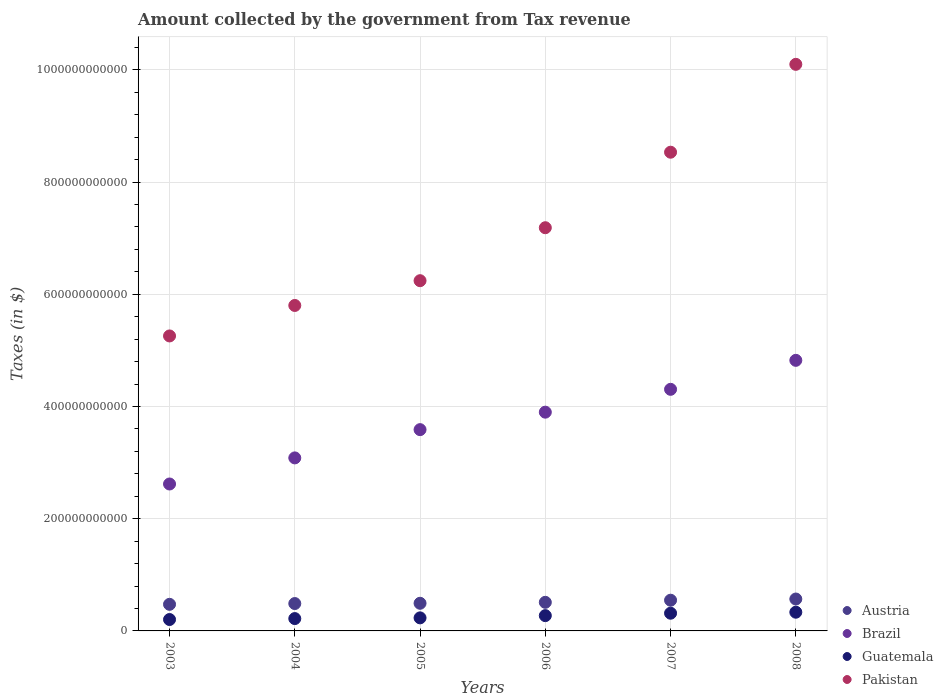How many different coloured dotlines are there?
Offer a very short reply. 4. What is the amount collected by the government from tax revenue in Brazil in 2005?
Your response must be concise. 3.59e+11. Across all years, what is the maximum amount collected by the government from tax revenue in Pakistan?
Provide a succinct answer. 1.01e+12. Across all years, what is the minimum amount collected by the government from tax revenue in Pakistan?
Your answer should be compact. 5.26e+11. In which year was the amount collected by the government from tax revenue in Brazil minimum?
Offer a terse response. 2003. What is the total amount collected by the government from tax revenue in Guatemala in the graph?
Keep it short and to the point. 1.58e+11. What is the difference between the amount collected by the government from tax revenue in Austria in 2003 and that in 2005?
Give a very brief answer. -1.86e+09. What is the difference between the amount collected by the government from tax revenue in Guatemala in 2003 and the amount collected by the government from tax revenue in Austria in 2007?
Give a very brief answer. -3.44e+1. What is the average amount collected by the government from tax revenue in Austria per year?
Give a very brief answer. 5.13e+1. In the year 2005, what is the difference between the amount collected by the government from tax revenue in Brazil and amount collected by the government from tax revenue in Guatemala?
Offer a very short reply. 3.35e+11. In how many years, is the amount collected by the government from tax revenue in Austria greater than 120000000000 $?
Your response must be concise. 0. What is the ratio of the amount collected by the government from tax revenue in Pakistan in 2003 to that in 2004?
Your answer should be compact. 0.91. Is the difference between the amount collected by the government from tax revenue in Brazil in 2007 and 2008 greater than the difference between the amount collected by the government from tax revenue in Guatemala in 2007 and 2008?
Your answer should be very brief. No. What is the difference between the highest and the second highest amount collected by the government from tax revenue in Brazil?
Ensure brevity in your answer.  5.17e+1. What is the difference between the highest and the lowest amount collected by the government from tax revenue in Guatemala?
Your response must be concise. 1.30e+1. In how many years, is the amount collected by the government from tax revenue in Pakistan greater than the average amount collected by the government from tax revenue in Pakistan taken over all years?
Ensure brevity in your answer.  3. Is the sum of the amount collected by the government from tax revenue in Brazil in 2005 and 2006 greater than the maximum amount collected by the government from tax revenue in Guatemala across all years?
Provide a short and direct response. Yes. Is it the case that in every year, the sum of the amount collected by the government from tax revenue in Guatemala and amount collected by the government from tax revenue in Austria  is greater than the sum of amount collected by the government from tax revenue in Brazil and amount collected by the government from tax revenue in Pakistan?
Your answer should be compact. Yes. Does the amount collected by the government from tax revenue in Pakistan monotonically increase over the years?
Your answer should be compact. Yes. Is the amount collected by the government from tax revenue in Pakistan strictly less than the amount collected by the government from tax revenue in Austria over the years?
Provide a short and direct response. No. How many dotlines are there?
Your answer should be very brief. 4. What is the difference between two consecutive major ticks on the Y-axis?
Ensure brevity in your answer.  2.00e+11. Are the values on the major ticks of Y-axis written in scientific E-notation?
Your answer should be very brief. No. Does the graph contain any zero values?
Keep it short and to the point. No. Where does the legend appear in the graph?
Provide a short and direct response. Bottom right. How many legend labels are there?
Your response must be concise. 4. What is the title of the graph?
Your response must be concise. Amount collected by the government from Tax revenue. Does "Euro area" appear as one of the legend labels in the graph?
Your answer should be very brief. No. What is the label or title of the X-axis?
Give a very brief answer. Years. What is the label or title of the Y-axis?
Offer a terse response. Taxes (in $). What is the Taxes (in $) of Austria in 2003?
Make the answer very short. 4.74e+1. What is the Taxes (in $) in Brazil in 2003?
Give a very brief answer. 2.62e+11. What is the Taxes (in $) of Guatemala in 2003?
Your answer should be very brief. 2.03e+1. What is the Taxes (in $) in Pakistan in 2003?
Your answer should be very brief. 5.26e+11. What is the Taxes (in $) in Austria in 2004?
Offer a very short reply. 4.88e+1. What is the Taxes (in $) of Brazil in 2004?
Your answer should be compact. 3.08e+11. What is the Taxes (in $) of Guatemala in 2004?
Your answer should be very brief. 2.20e+1. What is the Taxes (in $) in Pakistan in 2004?
Provide a short and direct response. 5.80e+11. What is the Taxes (in $) of Austria in 2005?
Ensure brevity in your answer.  4.93e+1. What is the Taxes (in $) in Brazil in 2005?
Your answer should be very brief. 3.59e+11. What is the Taxes (in $) of Guatemala in 2005?
Ensure brevity in your answer.  2.33e+1. What is the Taxes (in $) in Pakistan in 2005?
Provide a succinct answer. 6.24e+11. What is the Taxes (in $) of Austria in 2006?
Your response must be concise. 5.10e+1. What is the Taxes (in $) of Brazil in 2006?
Give a very brief answer. 3.90e+11. What is the Taxes (in $) in Guatemala in 2006?
Give a very brief answer. 2.73e+1. What is the Taxes (in $) of Pakistan in 2006?
Give a very brief answer. 7.19e+11. What is the Taxes (in $) of Austria in 2007?
Ensure brevity in your answer.  5.47e+1. What is the Taxes (in $) of Brazil in 2007?
Your answer should be compact. 4.31e+11. What is the Taxes (in $) of Guatemala in 2007?
Your answer should be very brief. 3.16e+1. What is the Taxes (in $) of Pakistan in 2007?
Keep it short and to the point. 8.53e+11. What is the Taxes (in $) of Austria in 2008?
Provide a short and direct response. 5.69e+1. What is the Taxes (in $) in Brazil in 2008?
Give a very brief answer. 4.82e+11. What is the Taxes (in $) in Guatemala in 2008?
Your response must be concise. 3.34e+1. What is the Taxes (in $) in Pakistan in 2008?
Your answer should be compact. 1.01e+12. Across all years, what is the maximum Taxes (in $) in Austria?
Your answer should be compact. 5.69e+1. Across all years, what is the maximum Taxes (in $) in Brazil?
Offer a terse response. 4.82e+11. Across all years, what is the maximum Taxes (in $) in Guatemala?
Make the answer very short. 3.34e+1. Across all years, what is the maximum Taxes (in $) of Pakistan?
Offer a terse response. 1.01e+12. Across all years, what is the minimum Taxes (in $) of Austria?
Ensure brevity in your answer.  4.74e+1. Across all years, what is the minimum Taxes (in $) of Brazil?
Offer a terse response. 2.62e+11. Across all years, what is the minimum Taxes (in $) of Guatemala?
Your response must be concise. 2.03e+1. Across all years, what is the minimum Taxes (in $) of Pakistan?
Give a very brief answer. 5.26e+11. What is the total Taxes (in $) of Austria in the graph?
Provide a short and direct response. 3.08e+11. What is the total Taxes (in $) of Brazil in the graph?
Your answer should be compact. 2.23e+12. What is the total Taxes (in $) in Guatemala in the graph?
Your response must be concise. 1.58e+11. What is the total Taxes (in $) in Pakistan in the graph?
Make the answer very short. 4.31e+12. What is the difference between the Taxes (in $) of Austria in 2003 and that in 2004?
Ensure brevity in your answer.  -1.38e+09. What is the difference between the Taxes (in $) in Brazil in 2003 and that in 2004?
Ensure brevity in your answer.  -4.65e+1. What is the difference between the Taxes (in $) in Guatemala in 2003 and that in 2004?
Provide a succinct answer. -1.68e+09. What is the difference between the Taxes (in $) in Pakistan in 2003 and that in 2004?
Offer a terse response. -5.43e+1. What is the difference between the Taxes (in $) of Austria in 2003 and that in 2005?
Your answer should be very brief. -1.86e+09. What is the difference between the Taxes (in $) in Brazil in 2003 and that in 2005?
Your answer should be very brief. -9.69e+1. What is the difference between the Taxes (in $) of Guatemala in 2003 and that in 2005?
Keep it short and to the point. -2.96e+09. What is the difference between the Taxes (in $) in Pakistan in 2003 and that in 2005?
Your response must be concise. -9.85e+1. What is the difference between the Taxes (in $) in Austria in 2003 and that in 2006?
Make the answer very short. -3.57e+09. What is the difference between the Taxes (in $) of Brazil in 2003 and that in 2006?
Your response must be concise. -1.28e+11. What is the difference between the Taxes (in $) of Guatemala in 2003 and that in 2006?
Make the answer very short. -6.93e+09. What is the difference between the Taxes (in $) of Pakistan in 2003 and that in 2006?
Offer a terse response. -1.93e+11. What is the difference between the Taxes (in $) of Austria in 2003 and that in 2007?
Provide a short and direct response. -7.33e+09. What is the difference between the Taxes (in $) in Brazil in 2003 and that in 2007?
Keep it short and to the point. -1.69e+11. What is the difference between the Taxes (in $) in Guatemala in 2003 and that in 2007?
Ensure brevity in your answer.  -1.12e+1. What is the difference between the Taxes (in $) of Pakistan in 2003 and that in 2007?
Offer a very short reply. -3.27e+11. What is the difference between the Taxes (in $) in Austria in 2003 and that in 2008?
Make the answer very short. -9.44e+09. What is the difference between the Taxes (in $) in Brazil in 2003 and that in 2008?
Offer a very short reply. -2.20e+11. What is the difference between the Taxes (in $) in Guatemala in 2003 and that in 2008?
Provide a short and direct response. -1.30e+1. What is the difference between the Taxes (in $) in Pakistan in 2003 and that in 2008?
Provide a succinct answer. -4.84e+11. What is the difference between the Taxes (in $) of Austria in 2004 and that in 2005?
Keep it short and to the point. -4.75e+08. What is the difference between the Taxes (in $) of Brazil in 2004 and that in 2005?
Provide a succinct answer. -5.04e+1. What is the difference between the Taxes (in $) in Guatemala in 2004 and that in 2005?
Your answer should be very brief. -1.28e+09. What is the difference between the Taxes (in $) of Pakistan in 2004 and that in 2005?
Make the answer very short. -4.42e+1. What is the difference between the Taxes (in $) of Austria in 2004 and that in 2006?
Provide a short and direct response. -2.19e+09. What is the difference between the Taxes (in $) of Brazil in 2004 and that in 2006?
Offer a terse response. -8.15e+1. What is the difference between the Taxes (in $) in Guatemala in 2004 and that in 2006?
Provide a succinct answer. -5.25e+09. What is the difference between the Taxes (in $) in Pakistan in 2004 and that in 2006?
Provide a short and direct response. -1.39e+11. What is the difference between the Taxes (in $) in Austria in 2004 and that in 2007?
Your answer should be very brief. -5.95e+09. What is the difference between the Taxes (in $) of Brazil in 2004 and that in 2007?
Your response must be concise. -1.22e+11. What is the difference between the Taxes (in $) of Guatemala in 2004 and that in 2007?
Ensure brevity in your answer.  -9.57e+09. What is the difference between the Taxes (in $) in Pakistan in 2004 and that in 2007?
Your answer should be very brief. -2.73e+11. What is the difference between the Taxes (in $) in Austria in 2004 and that in 2008?
Make the answer very short. -8.06e+09. What is the difference between the Taxes (in $) in Brazil in 2004 and that in 2008?
Your answer should be very brief. -1.74e+11. What is the difference between the Taxes (in $) of Guatemala in 2004 and that in 2008?
Your answer should be very brief. -1.14e+1. What is the difference between the Taxes (in $) in Pakistan in 2004 and that in 2008?
Keep it short and to the point. -4.30e+11. What is the difference between the Taxes (in $) in Austria in 2005 and that in 2006?
Provide a short and direct response. -1.71e+09. What is the difference between the Taxes (in $) in Brazil in 2005 and that in 2006?
Ensure brevity in your answer.  -3.11e+1. What is the difference between the Taxes (in $) in Guatemala in 2005 and that in 2006?
Make the answer very short. -3.97e+09. What is the difference between the Taxes (in $) of Pakistan in 2005 and that in 2006?
Your response must be concise. -9.44e+1. What is the difference between the Taxes (in $) in Austria in 2005 and that in 2007?
Provide a short and direct response. -5.47e+09. What is the difference between the Taxes (in $) of Brazil in 2005 and that in 2007?
Provide a succinct answer. -7.19e+1. What is the difference between the Taxes (in $) in Guatemala in 2005 and that in 2007?
Your answer should be compact. -8.29e+09. What is the difference between the Taxes (in $) of Pakistan in 2005 and that in 2007?
Make the answer very short. -2.29e+11. What is the difference between the Taxes (in $) in Austria in 2005 and that in 2008?
Provide a succinct answer. -7.59e+09. What is the difference between the Taxes (in $) of Brazil in 2005 and that in 2008?
Ensure brevity in your answer.  -1.24e+11. What is the difference between the Taxes (in $) of Guatemala in 2005 and that in 2008?
Offer a terse response. -1.01e+1. What is the difference between the Taxes (in $) of Pakistan in 2005 and that in 2008?
Provide a short and direct response. -3.86e+11. What is the difference between the Taxes (in $) in Austria in 2006 and that in 2007?
Make the answer very short. -3.76e+09. What is the difference between the Taxes (in $) in Brazil in 2006 and that in 2007?
Ensure brevity in your answer.  -4.07e+1. What is the difference between the Taxes (in $) in Guatemala in 2006 and that in 2007?
Make the answer very short. -4.32e+09. What is the difference between the Taxes (in $) in Pakistan in 2006 and that in 2007?
Your answer should be compact. -1.35e+11. What is the difference between the Taxes (in $) of Austria in 2006 and that in 2008?
Provide a short and direct response. -5.88e+09. What is the difference between the Taxes (in $) in Brazil in 2006 and that in 2008?
Your answer should be compact. -9.24e+1. What is the difference between the Taxes (in $) in Guatemala in 2006 and that in 2008?
Ensure brevity in your answer.  -6.10e+09. What is the difference between the Taxes (in $) in Pakistan in 2006 and that in 2008?
Keep it short and to the point. -2.91e+11. What is the difference between the Taxes (in $) of Austria in 2007 and that in 2008?
Your answer should be compact. -2.12e+09. What is the difference between the Taxes (in $) in Brazil in 2007 and that in 2008?
Offer a terse response. -5.17e+1. What is the difference between the Taxes (in $) of Guatemala in 2007 and that in 2008?
Your response must be concise. -1.79e+09. What is the difference between the Taxes (in $) of Pakistan in 2007 and that in 2008?
Provide a succinct answer. -1.57e+11. What is the difference between the Taxes (in $) of Austria in 2003 and the Taxes (in $) of Brazil in 2004?
Your answer should be compact. -2.61e+11. What is the difference between the Taxes (in $) of Austria in 2003 and the Taxes (in $) of Guatemala in 2004?
Offer a terse response. 2.54e+1. What is the difference between the Taxes (in $) of Austria in 2003 and the Taxes (in $) of Pakistan in 2004?
Your answer should be compact. -5.33e+11. What is the difference between the Taxes (in $) of Brazil in 2003 and the Taxes (in $) of Guatemala in 2004?
Provide a succinct answer. 2.40e+11. What is the difference between the Taxes (in $) in Brazil in 2003 and the Taxes (in $) in Pakistan in 2004?
Ensure brevity in your answer.  -3.18e+11. What is the difference between the Taxes (in $) of Guatemala in 2003 and the Taxes (in $) of Pakistan in 2004?
Give a very brief answer. -5.60e+11. What is the difference between the Taxes (in $) in Austria in 2003 and the Taxes (in $) in Brazil in 2005?
Your response must be concise. -3.11e+11. What is the difference between the Taxes (in $) of Austria in 2003 and the Taxes (in $) of Guatemala in 2005?
Offer a terse response. 2.41e+1. What is the difference between the Taxes (in $) in Austria in 2003 and the Taxes (in $) in Pakistan in 2005?
Your answer should be very brief. -5.77e+11. What is the difference between the Taxes (in $) of Brazil in 2003 and the Taxes (in $) of Guatemala in 2005?
Your response must be concise. 2.39e+11. What is the difference between the Taxes (in $) of Brazil in 2003 and the Taxes (in $) of Pakistan in 2005?
Your answer should be compact. -3.62e+11. What is the difference between the Taxes (in $) of Guatemala in 2003 and the Taxes (in $) of Pakistan in 2005?
Offer a terse response. -6.04e+11. What is the difference between the Taxes (in $) of Austria in 2003 and the Taxes (in $) of Brazil in 2006?
Keep it short and to the point. -3.42e+11. What is the difference between the Taxes (in $) of Austria in 2003 and the Taxes (in $) of Guatemala in 2006?
Ensure brevity in your answer.  2.02e+1. What is the difference between the Taxes (in $) of Austria in 2003 and the Taxes (in $) of Pakistan in 2006?
Ensure brevity in your answer.  -6.71e+11. What is the difference between the Taxes (in $) in Brazil in 2003 and the Taxes (in $) in Guatemala in 2006?
Keep it short and to the point. 2.35e+11. What is the difference between the Taxes (in $) of Brazil in 2003 and the Taxes (in $) of Pakistan in 2006?
Offer a terse response. -4.57e+11. What is the difference between the Taxes (in $) of Guatemala in 2003 and the Taxes (in $) of Pakistan in 2006?
Provide a succinct answer. -6.98e+11. What is the difference between the Taxes (in $) in Austria in 2003 and the Taxes (in $) in Brazil in 2007?
Your answer should be compact. -3.83e+11. What is the difference between the Taxes (in $) in Austria in 2003 and the Taxes (in $) in Guatemala in 2007?
Your answer should be compact. 1.58e+1. What is the difference between the Taxes (in $) of Austria in 2003 and the Taxes (in $) of Pakistan in 2007?
Provide a succinct answer. -8.06e+11. What is the difference between the Taxes (in $) in Brazil in 2003 and the Taxes (in $) in Guatemala in 2007?
Your answer should be compact. 2.30e+11. What is the difference between the Taxes (in $) of Brazil in 2003 and the Taxes (in $) of Pakistan in 2007?
Provide a short and direct response. -5.91e+11. What is the difference between the Taxes (in $) of Guatemala in 2003 and the Taxes (in $) of Pakistan in 2007?
Offer a very short reply. -8.33e+11. What is the difference between the Taxes (in $) in Austria in 2003 and the Taxes (in $) in Brazil in 2008?
Your response must be concise. -4.35e+11. What is the difference between the Taxes (in $) in Austria in 2003 and the Taxes (in $) in Guatemala in 2008?
Your answer should be compact. 1.41e+1. What is the difference between the Taxes (in $) of Austria in 2003 and the Taxes (in $) of Pakistan in 2008?
Provide a succinct answer. -9.62e+11. What is the difference between the Taxes (in $) of Brazil in 2003 and the Taxes (in $) of Guatemala in 2008?
Provide a succinct answer. 2.29e+11. What is the difference between the Taxes (in $) in Brazil in 2003 and the Taxes (in $) in Pakistan in 2008?
Provide a succinct answer. -7.48e+11. What is the difference between the Taxes (in $) in Guatemala in 2003 and the Taxes (in $) in Pakistan in 2008?
Your answer should be very brief. -9.90e+11. What is the difference between the Taxes (in $) in Austria in 2004 and the Taxes (in $) in Brazil in 2005?
Your answer should be compact. -3.10e+11. What is the difference between the Taxes (in $) of Austria in 2004 and the Taxes (in $) of Guatemala in 2005?
Keep it short and to the point. 2.55e+1. What is the difference between the Taxes (in $) in Austria in 2004 and the Taxes (in $) in Pakistan in 2005?
Your answer should be very brief. -5.75e+11. What is the difference between the Taxes (in $) of Brazil in 2004 and the Taxes (in $) of Guatemala in 2005?
Provide a short and direct response. 2.85e+11. What is the difference between the Taxes (in $) in Brazil in 2004 and the Taxes (in $) in Pakistan in 2005?
Give a very brief answer. -3.16e+11. What is the difference between the Taxes (in $) in Guatemala in 2004 and the Taxes (in $) in Pakistan in 2005?
Provide a succinct answer. -6.02e+11. What is the difference between the Taxes (in $) of Austria in 2004 and the Taxes (in $) of Brazil in 2006?
Your answer should be very brief. -3.41e+11. What is the difference between the Taxes (in $) in Austria in 2004 and the Taxes (in $) in Guatemala in 2006?
Make the answer very short. 2.15e+1. What is the difference between the Taxes (in $) in Austria in 2004 and the Taxes (in $) in Pakistan in 2006?
Ensure brevity in your answer.  -6.70e+11. What is the difference between the Taxes (in $) in Brazil in 2004 and the Taxes (in $) in Guatemala in 2006?
Offer a very short reply. 2.81e+11. What is the difference between the Taxes (in $) in Brazil in 2004 and the Taxes (in $) in Pakistan in 2006?
Provide a short and direct response. -4.10e+11. What is the difference between the Taxes (in $) in Guatemala in 2004 and the Taxes (in $) in Pakistan in 2006?
Provide a short and direct response. -6.97e+11. What is the difference between the Taxes (in $) of Austria in 2004 and the Taxes (in $) of Brazil in 2007?
Your answer should be compact. -3.82e+11. What is the difference between the Taxes (in $) of Austria in 2004 and the Taxes (in $) of Guatemala in 2007?
Provide a short and direct response. 1.72e+1. What is the difference between the Taxes (in $) of Austria in 2004 and the Taxes (in $) of Pakistan in 2007?
Make the answer very short. -8.04e+11. What is the difference between the Taxes (in $) of Brazil in 2004 and the Taxes (in $) of Guatemala in 2007?
Your answer should be very brief. 2.77e+11. What is the difference between the Taxes (in $) in Brazil in 2004 and the Taxes (in $) in Pakistan in 2007?
Your answer should be compact. -5.45e+11. What is the difference between the Taxes (in $) in Guatemala in 2004 and the Taxes (in $) in Pakistan in 2007?
Provide a succinct answer. -8.31e+11. What is the difference between the Taxes (in $) in Austria in 2004 and the Taxes (in $) in Brazil in 2008?
Give a very brief answer. -4.34e+11. What is the difference between the Taxes (in $) in Austria in 2004 and the Taxes (in $) in Guatemala in 2008?
Make the answer very short. 1.54e+1. What is the difference between the Taxes (in $) in Austria in 2004 and the Taxes (in $) in Pakistan in 2008?
Your response must be concise. -9.61e+11. What is the difference between the Taxes (in $) in Brazil in 2004 and the Taxes (in $) in Guatemala in 2008?
Make the answer very short. 2.75e+11. What is the difference between the Taxes (in $) in Brazil in 2004 and the Taxes (in $) in Pakistan in 2008?
Keep it short and to the point. -7.02e+11. What is the difference between the Taxes (in $) of Guatemala in 2004 and the Taxes (in $) of Pakistan in 2008?
Offer a terse response. -9.88e+11. What is the difference between the Taxes (in $) in Austria in 2005 and the Taxes (in $) in Brazil in 2006?
Keep it short and to the point. -3.41e+11. What is the difference between the Taxes (in $) of Austria in 2005 and the Taxes (in $) of Guatemala in 2006?
Your response must be concise. 2.20e+1. What is the difference between the Taxes (in $) of Austria in 2005 and the Taxes (in $) of Pakistan in 2006?
Offer a very short reply. -6.69e+11. What is the difference between the Taxes (in $) of Brazil in 2005 and the Taxes (in $) of Guatemala in 2006?
Keep it short and to the point. 3.32e+11. What is the difference between the Taxes (in $) in Brazil in 2005 and the Taxes (in $) in Pakistan in 2006?
Offer a terse response. -3.60e+11. What is the difference between the Taxes (in $) in Guatemala in 2005 and the Taxes (in $) in Pakistan in 2006?
Keep it short and to the point. -6.95e+11. What is the difference between the Taxes (in $) in Austria in 2005 and the Taxes (in $) in Brazil in 2007?
Offer a terse response. -3.81e+11. What is the difference between the Taxes (in $) in Austria in 2005 and the Taxes (in $) in Guatemala in 2007?
Give a very brief answer. 1.77e+1. What is the difference between the Taxes (in $) of Austria in 2005 and the Taxes (in $) of Pakistan in 2007?
Offer a terse response. -8.04e+11. What is the difference between the Taxes (in $) of Brazil in 2005 and the Taxes (in $) of Guatemala in 2007?
Ensure brevity in your answer.  3.27e+11. What is the difference between the Taxes (in $) of Brazil in 2005 and the Taxes (in $) of Pakistan in 2007?
Your answer should be very brief. -4.94e+11. What is the difference between the Taxes (in $) in Guatemala in 2005 and the Taxes (in $) in Pakistan in 2007?
Your answer should be very brief. -8.30e+11. What is the difference between the Taxes (in $) in Austria in 2005 and the Taxes (in $) in Brazil in 2008?
Your answer should be very brief. -4.33e+11. What is the difference between the Taxes (in $) in Austria in 2005 and the Taxes (in $) in Guatemala in 2008?
Ensure brevity in your answer.  1.59e+1. What is the difference between the Taxes (in $) of Austria in 2005 and the Taxes (in $) of Pakistan in 2008?
Make the answer very short. -9.61e+11. What is the difference between the Taxes (in $) of Brazil in 2005 and the Taxes (in $) of Guatemala in 2008?
Provide a succinct answer. 3.25e+11. What is the difference between the Taxes (in $) of Brazil in 2005 and the Taxes (in $) of Pakistan in 2008?
Provide a short and direct response. -6.51e+11. What is the difference between the Taxes (in $) in Guatemala in 2005 and the Taxes (in $) in Pakistan in 2008?
Your answer should be compact. -9.87e+11. What is the difference between the Taxes (in $) in Austria in 2006 and the Taxes (in $) in Brazil in 2007?
Your response must be concise. -3.80e+11. What is the difference between the Taxes (in $) of Austria in 2006 and the Taxes (in $) of Guatemala in 2007?
Your answer should be compact. 1.94e+1. What is the difference between the Taxes (in $) of Austria in 2006 and the Taxes (in $) of Pakistan in 2007?
Give a very brief answer. -8.02e+11. What is the difference between the Taxes (in $) in Brazil in 2006 and the Taxes (in $) in Guatemala in 2007?
Provide a short and direct response. 3.58e+11. What is the difference between the Taxes (in $) of Brazil in 2006 and the Taxes (in $) of Pakistan in 2007?
Give a very brief answer. -4.63e+11. What is the difference between the Taxes (in $) of Guatemala in 2006 and the Taxes (in $) of Pakistan in 2007?
Offer a terse response. -8.26e+11. What is the difference between the Taxes (in $) in Austria in 2006 and the Taxes (in $) in Brazil in 2008?
Give a very brief answer. -4.31e+11. What is the difference between the Taxes (in $) of Austria in 2006 and the Taxes (in $) of Guatemala in 2008?
Your answer should be very brief. 1.76e+1. What is the difference between the Taxes (in $) in Austria in 2006 and the Taxes (in $) in Pakistan in 2008?
Provide a short and direct response. -9.59e+11. What is the difference between the Taxes (in $) in Brazil in 2006 and the Taxes (in $) in Guatemala in 2008?
Your response must be concise. 3.57e+11. What is the difference between the Taxes (in $) in Brazil in 2006 and the Taxes (in $) in Pakistan in 2008?
Offer a very short reply. -6.20e+11. What is the difference between the Taxes (in $) of Guatemala in 2006 and the Taxes (in $) of Pakistan in 2008?
Offer a very short reply. -9.83e+11. What is the difference between the Taxes (in $) in Austria in 2007 and the Taxes (in $) in Brazil in 2008?
Give a very brief answer. -4.28e+11. What is the difference between the Taxes (in $) of Austria in 2007 and the Taxes (in $) of Guatemala in 2008?
Provide a short and direct response. 2.14e+1. What is the difference between the Taxes (in $) in Austria in 2007 and the Taxes (in $) in Pakistan in 2008?
Provide a short and direct response. -9.55e+11. What is the difference between the Taxes (in $) of Brazil in 2007 and the Taxes (in $) of Guatemala in 2008?
Your response must be concise. 3.97e+11. What is the difference between the Taxes (in $) in Brazil in 2007 and the Taxes (in $) in Pakistan in 2008?
Make the answer very short. -5.79e+11. What is the difference between the Taxes (in $) of Guatemala in 2007 and the Taxes (in $) of Pakistan in 2008?
Give a very brief answer. -9.78e+11. What is the average Taxes (in $) in Austria per year?
Keep it short and to the point. 5.13e+1. What is the average Taxes (in $) of Brazil per year?
Give a very brief answer. 3.72e+11. What is the average Taxes (in $) in Guatemala per year?
Your answer should be very brief. 2.63e+1. What is the average Taxes (in $) of Pakistan per year?
Ensure brevity in your answer.  7.19e+11. In the year 2003, what is the difference between the Taxes (in $) in Austria and Taxes (in $) in Brazil?
Offer a terse response. -2.14e+11. In the year 2003, what is the difference between the Taxes (in $) of Austria and Taxes (in $) of Guatemala?
Offer a terse response. 2.71e+1. In the year 2003, what is the difference between the Taxes (in $) of Austria and Taxes (in $) of Pakistan?
Provide a short and direct response. -4.78e+11. In the year 2003, what is the difference between the Taxes (in $) in Brazil and Taxes (in $) in Guatemala?
Provide a succinct answer. 2.42e+11. In the year 2003, what is the difference between the Taxes (in $) of Brazil and Taxes (in $) of Pakistan?
Provide a short and direct response. -2.64e+11. In the year 2003, what is the difference between the Taxes (in $) in Guatemala and Taxes (in $) in Pakistan?
Give a very brief answer. -5.05e+11. In the year 2004, what is the difference between the Taxes (in $) of Austria and Taxes (in $) of Brazil?
Give a very brief answer. -2.60e+11. In the year 2004, what is the difference between the Taxes (in $) in Austria and Taxes (in $) in Guatemala?
Your answer should be compact. 2.68e+1. In the year 2004, what is the difference between the Taxes (in $) in Austria and Taxes (in $) in Pakistan?
Your answer should be compact. -5.31e+11. In the year 2004, what is the difference between the Taxes (in $) in Brazil and Taxes (in $) in Guatemala?
Your answer should be very brief. 2.86e+11. In the year 2004, what is the difference between the Taxes (in $) of Brazil and Taxes (in $) of Pakistan?
Your answer should be compact. -2.72e+11. In the year 2004, what is the difference between the Taxes (in $) of Guatemala and Taxes (in $) of Pakistan?
Your response must be concise. -5.58e+11. In the year 2005, what is the difference between the Taxes (in $) of Austria and Taxes (in $) of Brazil?
Provide a succinct answer. -3.10e+11. In the year 2005, what is the difference between the Taxes (in $) of Austria and Taxes (in $) of Guatemala?
Keep it short and to the point. 2.60e+1. In the year 2005, what is the difference between the Taxes (in $) in Austria and Taxes (in $) in Pakistan?
Make the answer very short. -5.75e+11. In the year 2005, what is the difference between the Taxes (in $) in Brazil and Taxes (in $) in Guatemala?
Ensure brevity in your answer.  3.35e+11. In the year 2005, what is the difference between the Taxes (in $) in Brazil and Taxes (in $) in Pakistan?
Offer a terse response. -2.65e+11. In the year 2005, what is the difference between the Taxes (in $) in Guatemala and Taxes (in $) in Pakistan?
Offer a terse response. -6.01e+11. In the year 2006, what is the difference between the Taxes (in $) in Austria and Taxes (in $) in Brazil?
Offer a terse response. -3.39e+11. In the year 2006, what is the difference between the Taxes (in $) of Austria and Taxes (in $) of Guatemala?
Give a very brief answer. 2.37e+1. In the year 2006, what is the difference between the Taxes (in $) in Austria and Taxes (in $) in Pakistan?
Keep it short and to the point. -6.68e+11. In the year 2006, what is the difference between the Taxes (in $) in Brazil and Taxes (in $) in Guatemala?
Provide a succinct answer. 3.63e+11. In the year 2006, what is the difference between the Taxes (in $) of Brazil and Taxes (in $) of Pakistan?
Provide a succinct answer. -3.29e+11. In the year 2006, what is the difference between the Taxes (in $) in Guatemala and Taxes (in $) in Pakistan?
Ensure brevity in your answer.  -6.91e+11. In the year 2007, what is the difference between the Taxes (in $) in Austria and Taxes (in $) in Brazil?
Provide a short and direct response. -3.76e+11. In the year 2007, what is the difference between the Taxes (in $) in Austria and Taxes (in $) in Guatemala?
Provide a short and direct response. 2.32e+1. In the year 2007, what is the difference between the Taxes (in $) in Austria and Taxes (in $) in Pakistan?
Give a very brief answer. -7.99e+11. In the year 2007, what is the difference between the Taxes (in $) of Brazil and Taxes (in $) of Guatemala?
Offer a very short reply. 3.99e+11. In the year 2007, what is the difference between the Taxes (in $) in Brazil and Taxes (in $) in Pakistan?
Your response must be concise. -4.23e+11. In the year 2007, what is the difference between the Taxes (in $) in Guatemala and Taxes (in $) in Pakistan?
Your answer should be very brief. -8.22e+11. In the year 2008, what is the difference between the Taxes (in $) in Austria and Taxes (in $) in Brazil?
Keep it short and to the point. -4.25e+11. In the year 2008, what is the difference between the Taxes (in $) of Austria and Taxes (in $) of Guatemala?
Offer a terse response. 2.35e+1. In the year 2008, what is the difference between the Taxes (in $) of Austria and Taxes (in $) of Pakistan?
Make the answer very short. -9.53e+11. In the year 2008, what is the difference between the Taxes (in $) in Brazil and Taxes (in $) in Guatemala?
Your response must be concise. 4.49e+11. In the year 2008, what is the difference between the Taxes (in $) of Brazil and Taxes (in $) of Pakistan?
Offer a terse response. -5.28e+11. In the year 2008, what is the difference between the Taxes (in $) in Guatemala and Taxes (in $) in Pakistan?
Offer a very short reply. -9.77e+11. What is the ratio of the Taxes (in $) of Austria in 2003 to that in 2004?
Offer a terse response. 0.97. What is the ratio of the Taxes (in $) in Brazil in 2003 to that in 2004?
Provide a short and direct response. 0.85. What is the ratio of the Taxes (in $) in Guatemala in 2003 to that in 2004?
Your response must be concise. 0.92. What is the ratio of the Taxes (in $) in Pakistan in 2003 to that in 2004?
Ensure brevity in your answer.  0.91. What is the ratio of the Taxes (in $) in Austria in 2003 to that in 2005?
Offer a terse response. 0.96. What is the ratio of the Taxes (in $) in Brazil in 2003 to that in 2005?
Offer a terse response. 0.73. What is the ratio of the Taxes (in $) in Guatemala in 2003 to that in 2005?
Your answer should be compact. 0.87. What is the ratio of the Taxes (in $) of Pakistan in 2003 to that in 2005?
Provide a short and direct response. 0.84. What is the ratio of the Taxes (in $) of Brazil in 2003 to that in 2006?
Offer a terse response. 0.67. What is the ratio of the Taxes (in $) in Guatemala in 2003 to that in 2006?
Your response must be concise. 0.75. What is the ratio of the Taxes (in $) of Pakistan in 2003 to that in 2006?
Keep it short and to the point. 0.73. What is the ratio of the Taxes (in $) in Austria in 2003 to that in 2007?
Your response must be concise. 0.87. What is the ratio of the Taxes (in $) of Brazil in 2003 to that in 2007?
Offer a terse response. 0.61. What is the ratio of the Taxes (in $) in Guatemala in 2003 to that in 2007?
Ensure brevity in your answer.  0.64. What is the ratio of the Taxes (in $) of Pakistan in 2003 to that in 2007?
Offer a terse response. 0.62. What is the ratio of the Taxes (in $) in Austria in 2003 to that in 2008?
Provide a succinct answer. 0.83. What is the ratio of the Taxes (in $) in Brazil in 2003 to that in 2008?
Offer a very short reply. 0.54. What is the ratio of the Taxes (in $) in Guatemala in 2003 to that in 2008?
Your response must be concise. 0.61. What is the ratio of the Taxes (in $) of Pakistan in 2003 to that in 2008?
Provide a short and direct response. 0.52. What is the ratio of the Taxes (in $) in Austria in 2004 to that in 2005?
Offer a very short reply. 0.99. What is the ratio of the Taxes (in $) in Brazil in 2004 to that in 2005?
Ensure brevity in your answer.  0.86. What is the ratio of the Taxes (in $) of Guatemala in 2004 to that in 2005?
Provide a short and direct response. 0.95. What is the ratio of the Taxes (in $) of Pakistan in 2004 to that in 2005?
Offer a very short reply. 0.93. What is the ratio of the Taxes (in $) in Austria in 2004 to that in 2006?
Your answer should be very brief. 0.96. What is the ratio of the Taxes (in $) in Brazil in 2004 to that in 2006?
Provide a succinct answer. 0.79. What is the ratio of the Taxes (in $) in Guatemala in 2004 to that in 2006?
Provide a succinct answer. 0.81. What is the ratio of the Taxes (in $) of Pakistan in 2004 to that in 2006?
Offer a terse response. 0.81. What is the ratio of the Taxes (in $) in Austria in 2004 to that in 2007?
Make the answer very short. 0.89. What is the ratio of the Taxes (in $) in Brazil in 2004 to that in 2007?
Offer a very short reply. 0.72. What is the ratio of the Taxes (in $) of Guatemala in 2004 to that in 2007?
Offer a very short reply. 0.7. What is the ratio of the Taxes (in $) of Pakistan in 2004 to that in 2007?
Give a very brief answer. 0.68. What is the ratio of the Taxes (in $) in Austria in 2004 to that in 2008?
Ensure brevity in your answer.  0.86. What is the ratio of the Taxes (in $) of Brazil in 2004 to that in 2008?
Give a very brief answer. 0.64. What is the ratio of the Taxes (in $) of Guatemala in 2004 to that in 2008?
Give a very brief answer. 0.66. What is the ratio of the Taxes (in $) of Pakistan in 2004 to that in 2008?
Offer a very short reply. 0.57. What is the ratio of the Taxes (in $) of Austria in 2005 to that in 2006?
Ensure brevity in your answer.  0.97. What is the ratio of the Taxes (in $) in Brazil in 2005 to that in 2006?
Your answer should be compact. 0.92. What is the ratio of the Taxes (in $) of Guatemala in 2005 to that in 2006?
Make the answer very short. 0.85. What is the ratio of the Taxes (in $) in Pakistan in 2005 to that in 2006?
Your answer should be very brief. 0.87. What is the ratio of the Taxes (in $) of Brazil in 2005 to that in 2007?
Provide a short and direct response. 0.83. What is the ratio of the Taxes (in $) of Guatemala in 2005 to that in 2007?
Provide a short and direct response. 0.74. What is the ratio of the Taxes (in $) in Pakistan in 2005 to that in 2007?
Your answer should be very brief. 0.73. What is the ratio of the Taxes (in $) of Austria in 2005 to that in 2008?
Provide a short and direct response. 0.87. What is the ratio of the Taxes (in $) of Brazil in 2005 to that in 2008?
Provide a succinct answer. 0.74. What is the ratio of the Taxes (in $) of Guatemala in 2005 to that in 2008?
Your answer should be very brief. 0.7. What is the ratio of the Taxes (in $) of Pakistan in 2005 to that in 2008?
Offer a terse response. 0.62. What is the ratio of the Taxes (in $) of Austria in 2006 to that in 2007?
Your answer should be compact. 0.93. What is the ratio of the Taxes (in $) in Brazil in 2006 to that in 2007?
Provide a succinct answer. 0.91. What is the ratio of the Taxes (in $) of Guatemala in 2006 to that in 2007?
Your response must be concise. 0.86. What is the ratio of the Taxes (in $) in Pakistan in 2006 to that in 2007?
Make the answer very short. 0.84. What is the ratio of the Taxes (in $) in Austria in 2006 to that in 2008?
Make the answer very short. 0.9. What is the ratio of the Taxes (in $) in Brazil in 2006 to that in 2008?
Ensure brevity in your answer.  0.81. What is the ratio of the Taxes (in $) of Guatemala in 2006 to that in 2008?
Make the answer very short. 0.82. What is the ratio of the Taxes (in $) of Pakistan in 2006 to that in 2008?
Your response must be concise. 0.71. What is the ratio of the Taxes (in $) of Austria in 2007 to that in 2008?
Your response must be concise. 0.96. What is the ratio of the Taxes (in $) in Brazil in 2007 to that in 2008?
Keep it short and to the point. 0.89. What is the ratio of the Taxes (in $) in Guatemala in 2007 to that in 2008?
Keep it short and to the point. 0.95. What is the ratio of the Taxes (in $) in Pakistan in 2007 to that in 2008?
Ensure brevity in your answer.  0.84. What is the difference between the highest and the second highest Taxes (in $) in Austria?
Keep it short and to the point. 2.12e+09. What is the difference between the highest and the second highest Taxes (in $) in Brazil?
Make the answer very short. 5.17e+1. What is the difference between the highest and the second highest Taxes (in $) of Guatemala?
Your answer should be very brief. 1.79e+09. What is the difference between the highest and the second highest Taxes (in $) in Pakistan?
Your answer should be very brief. 1.57e+11. What is the difference between the highest and the lowest Taxes (in $) of Austria?
Make the answer very short. 9.44e+09. What is the difference between the highest and the lowest Taxes (in $) of Brazil?
Your answer should be compact. 2.20e+11. What is the difference between the highest and the lowest Taxes (in $) in Guatemala?
Give a very brief answer. 1.30e+1. What is the difference between the highest and the lowest Taxes (in $) of Pakistan?
Make the answer very short. 4.84e+11. 